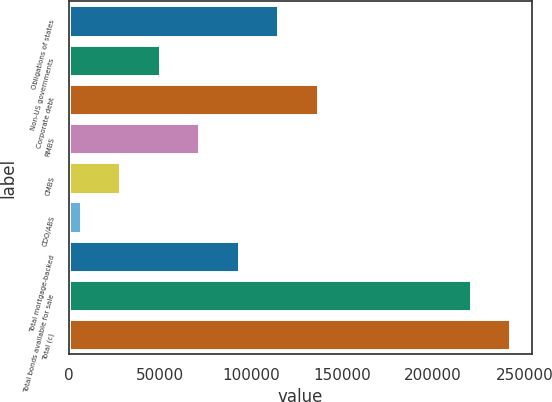Convert chart to OTSL. <chart><loc_0><loc_0><loc_500><loc_500><bar_chart><fcel>Obligations of states<fcel>Non-US governments<fcel>Corporate debt<fcel>RMBS<fcel>CMBS<fcel>CDO/ABS<fcel>Total mortgage-backed<fcel>Total bonds available for sale<fcel>Total (c)<nl><fcel>114942<fcel>49962.4<fcel>136601<fcel>71622.1<fcel>28302.7<fcel>6643<fcel>93281.8<fcel>220669<fcel>242329<nl></chart> 